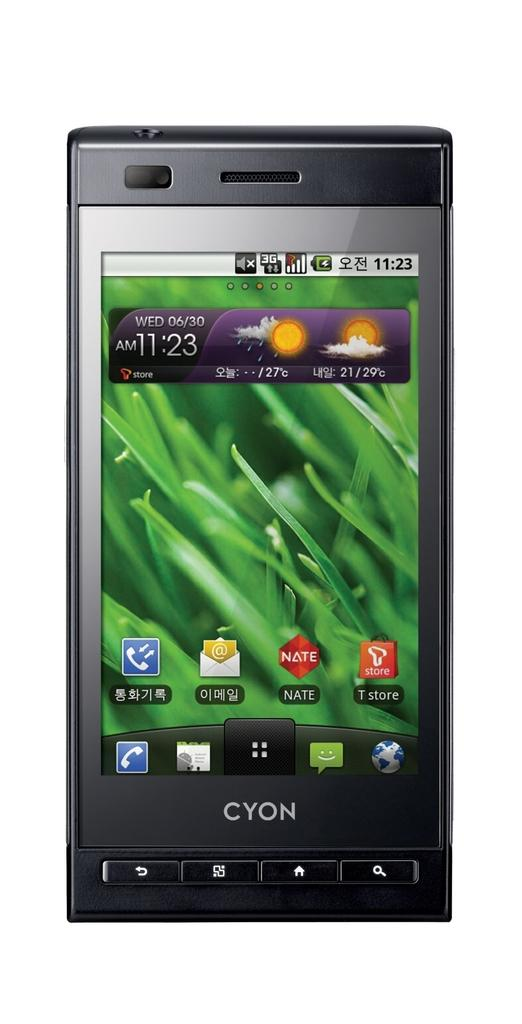<image>
Offer a succinct explanation of the picture presented. The desktop screen on a Cyon branded cellphone shows the weather, a few applications and a close up picture of green grass. 